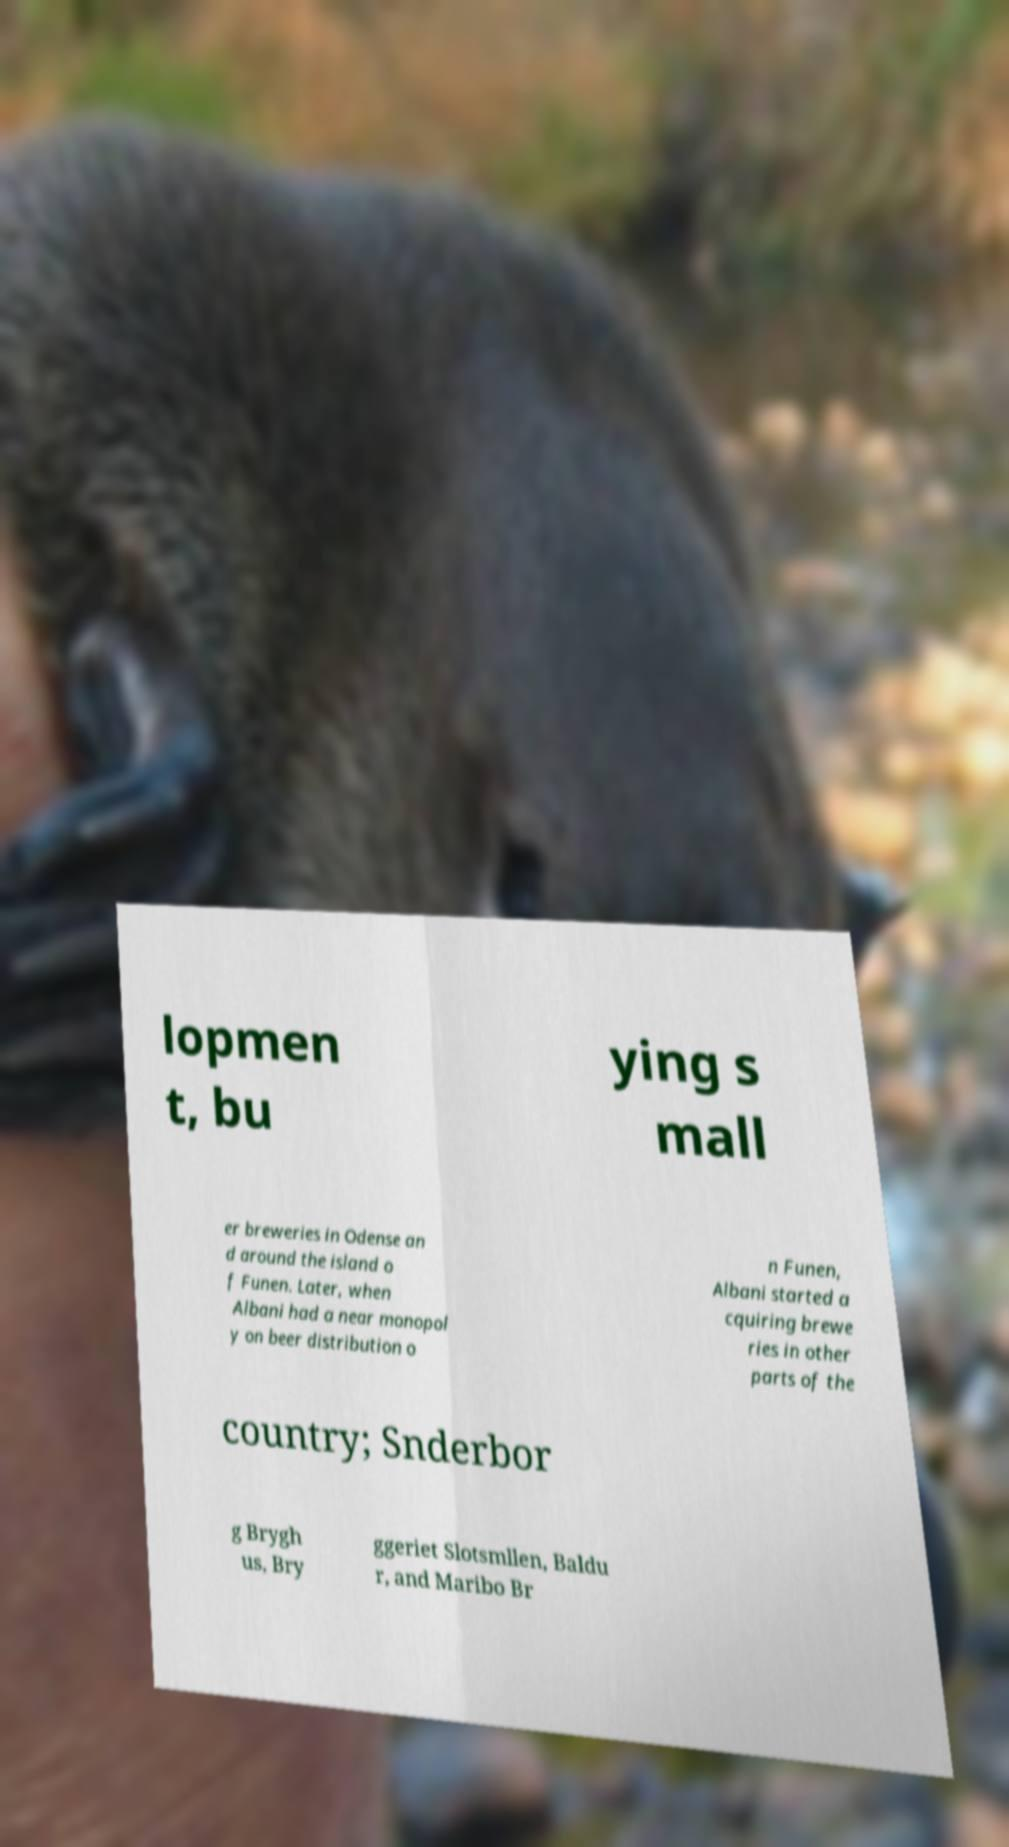Could you extract and type out the text from this image? lopmen t, bu ying s mall er breweries in Odense an d around the island o f Funen. Later, when Albani had a near monopol y on beer distribution o n Funen, Albani started a cquiring brewe ries in other parts of the country; Snderbor g Brygh us, Bry ggeriet Slotsmllen, Baldu r, and Maribo Br 